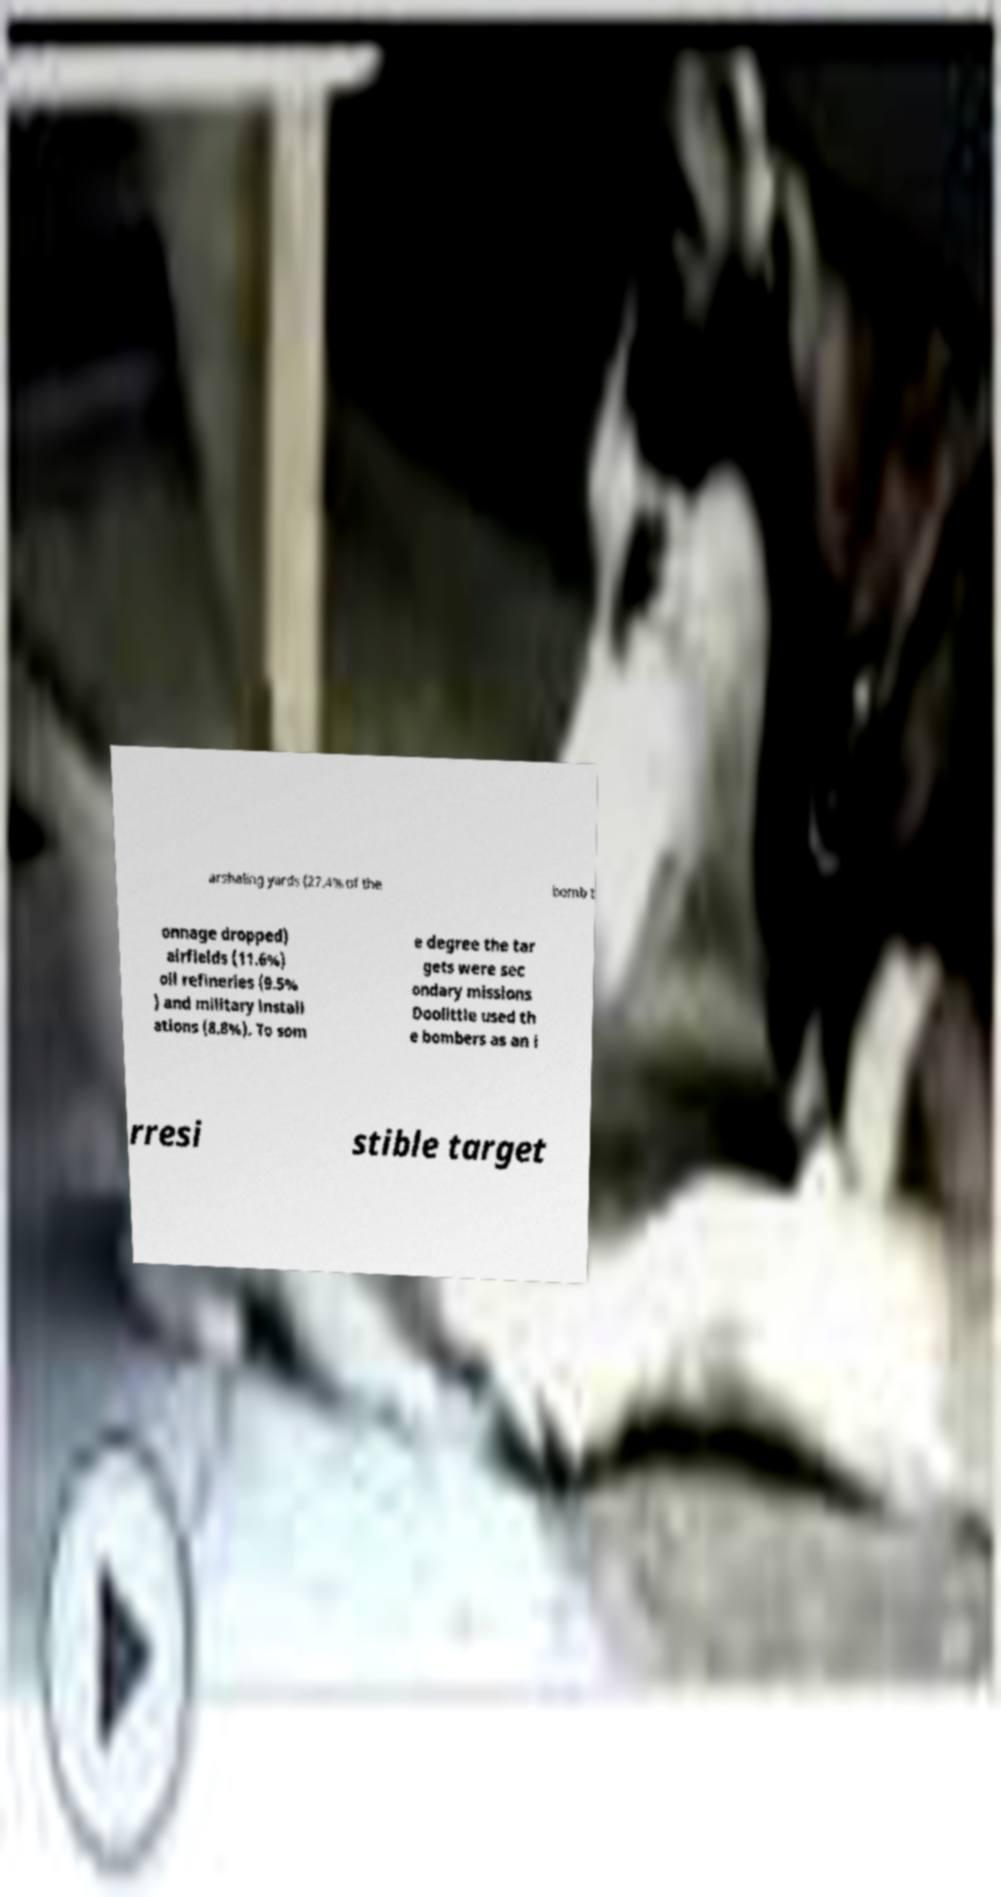Please read and relay the text visible in this image. What does it say? arshaling yards (27.4% of the bomb t onnage dropped) airfields (11.6%) oil refineries (9.5% ) and military install ations (8.8%). To som e degree the tar gets were sec ondary missions Doolittle used th e bombers as an i rresi stible target 